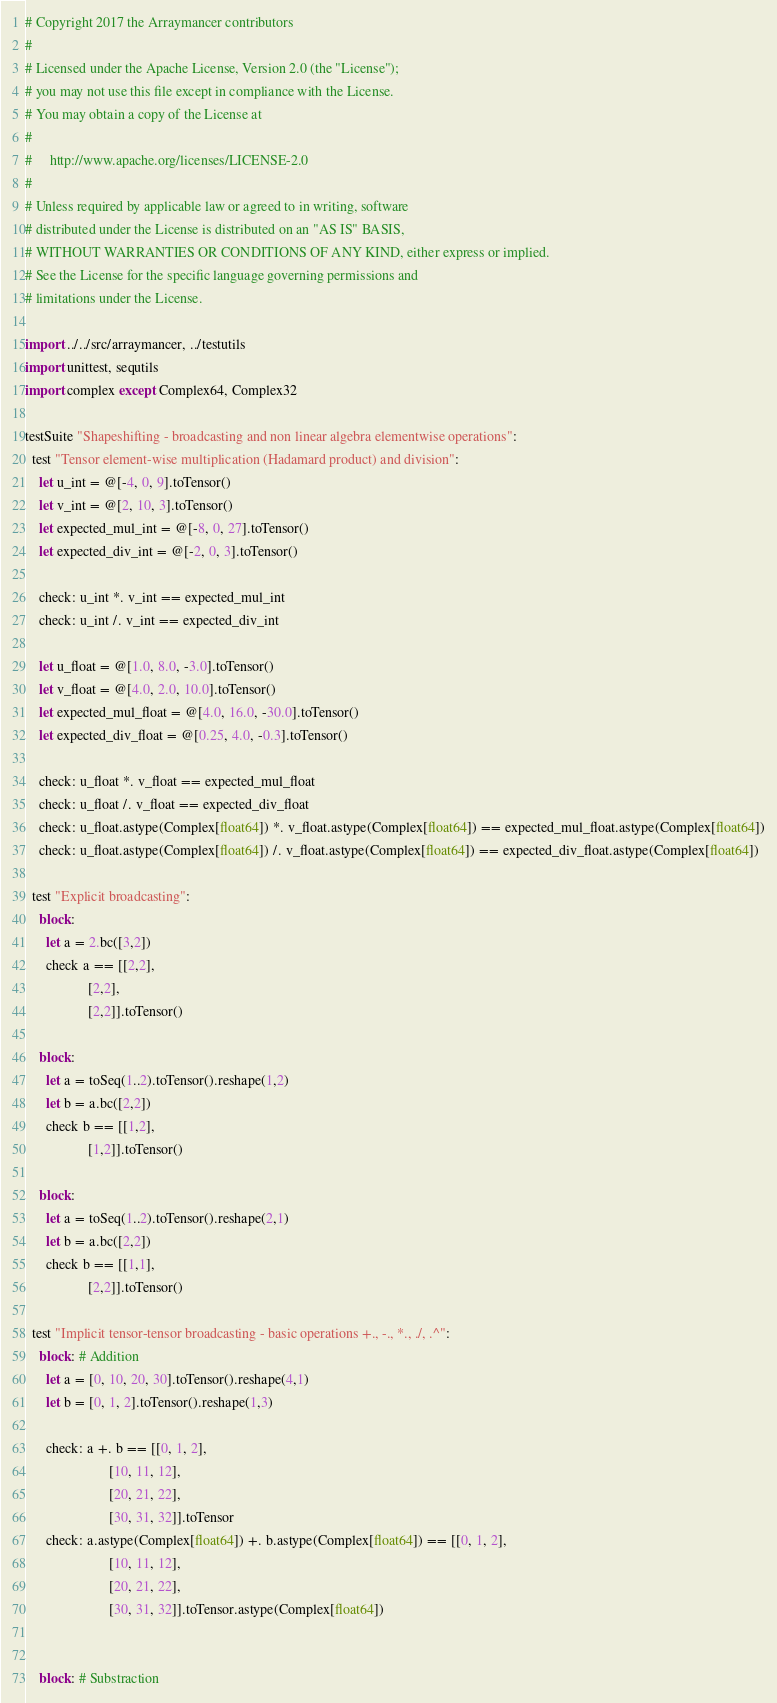Convert code to text. <code><loc_0><loc_0><loc_500><loc_500><_Nim_># Copyright 2017 the Arraymancer contributors
#
# Licensed under the Apache License, Version 2.0 (the "License");
# you may not use this file except in compliance with the License.
# You may obtain a copy of the License at
#
#     http://www.apache.org/licenses/LICENSE-2.0
#
# Unless required by applicable law or agreed to in writing, software
# distributed under the License is distributed on an "AS IS" BASIS,
# WITHOUT WARRANTIES OR CONDITIONS OF ANY KIND, either express or implied.
# See the License for the specific language governing permissions and
# limitations under the License.

import ../../src/arraymancer, ../testutils
import unittest, sequtils
import complex except Complex64, Complex32

testSuite "Shapeshifting - broadcasting and non linear algebra elementwise operations":
  test "Tensor element-wise multiplication (Hadamard product) and division":
    let u_int = @[-4, 0, 9].toTensor()
    let v_int = @[2, 10, 3].toTensor()
    let expected_mul_int = @[-8, 0, 27].toTensor()
    let expected_div_int = @[-2, 0, 3].toTensor()

    check: u_int *. v_int == expected_mul_int
    check: u_int /. v_int == expected_div_int

    let u_float = @[1.0, 8.0, -3.0].toTensor()
    let v_float = @[4.0, 2.0, 10.0].toTensor()
    let expected_mul_float = @[4.0, 16.0, -30.0].toTensor()
    let expected_div_float = @[0.25, 4.0, -0.3].toTensor()

    check: u_float *. v_float == expected_mul_float
    check: u_float /. v_float == expected_div_float
    check: u_float.astype(Complex[float64]) *. v_float.astype(Complex[float64]) == expected_mul_float.astype(Complex[float64])
    check: u_float.astype(Complex[float64]) /. v_float.astype(Complex[float64]) == expected_div_float.astype(Complex[float64])

  test "Explicit broadcasting":
    block:
      let a = 2.bc([3,2])
      check a == [[2,2],
                  [2,2],
                  [2,2]].toTensor()

    block:
      let a = toSeq(1..2).toTensor().reshape(1,2)
      let b = a.bc([2,2])
      check b == [[1,2],
                  [1,2]].toTensor()

    block:
      let a = toSeq(1..2).toTensor().reshape(2,1)
      let b = a.bc([2,2])
      check b == [[1,1],
                  [2,2]].toTensor()

  test "Implicit tensor-tensor broadcasting - basic operations +., -., *., ./, .^":
    block: # Addition
      let a = [0, 10, 20, 30].toTensor().reshape(4,1)
      let b = [0, 1, 2].toTensor().reshape(1,3)

      check: a +. b == [[0, 1, 2],
                        [10, 11, 12],
                        [20, 21, 22],
                        [30, 31, 32]].toTensor
      check: a.astype(Complex[float64]) +. b.astype(Complex[float64]) == [[0, 1, 2],
                        [10, 11, 12],
                        [20, 21, 22],
                        [30, 31, 32]].toTensor.astype(Complex[float64])


    block: # Substraction</code> 